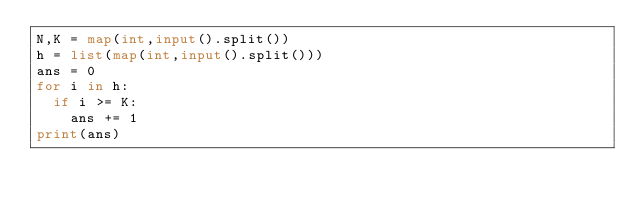<code> <loc_0><loc_0><loc_500><loc_500><_Python_>N,K = map(int,input().split())
h = list(map(int,input().split()))
ans = 0
for i in h:
  if i >= K:
    ans += 1
print(ans)</code> 